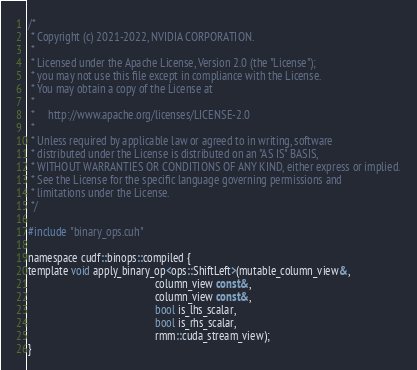<code> <loc_0><loc_0><loc_500><loc_500><_Cuda_>/*
 * Copyright (c) 2021-2022, NVIDIA CORPORATION.
 *
 * Licensed under the Apache License, Version 2.0 (the "License");
 * you may not use this file except in compliance with the License.
 * You may obtain a copy of the License at
 *
 *     http://www.apache.org/licenses/LICENSE-2.0
 *
 * Unless required by applicable law or agreed to in writing, software
 * distributed under the License is distributed on an "AS IS" BASIS,
 * WITHOUT WARRANTIES OR CONDITIONS OF ANY KIND, either express or implied.
 * See the License for the specific language governing permissions and
 * limitations under the License.
 */

#include "binary_ops.cuh"

namespace cudf::binops::compiled {
template void apply_binary_op<ops::ShiftLeft>(mutable_column_view&,
                                              column_view const&,
                                              column_view const&,
                                              bool is_lhs_scalar,
                                              bool is_rhs_scalar,
                                              rmm::cuda_stream_view);
}
</code> 